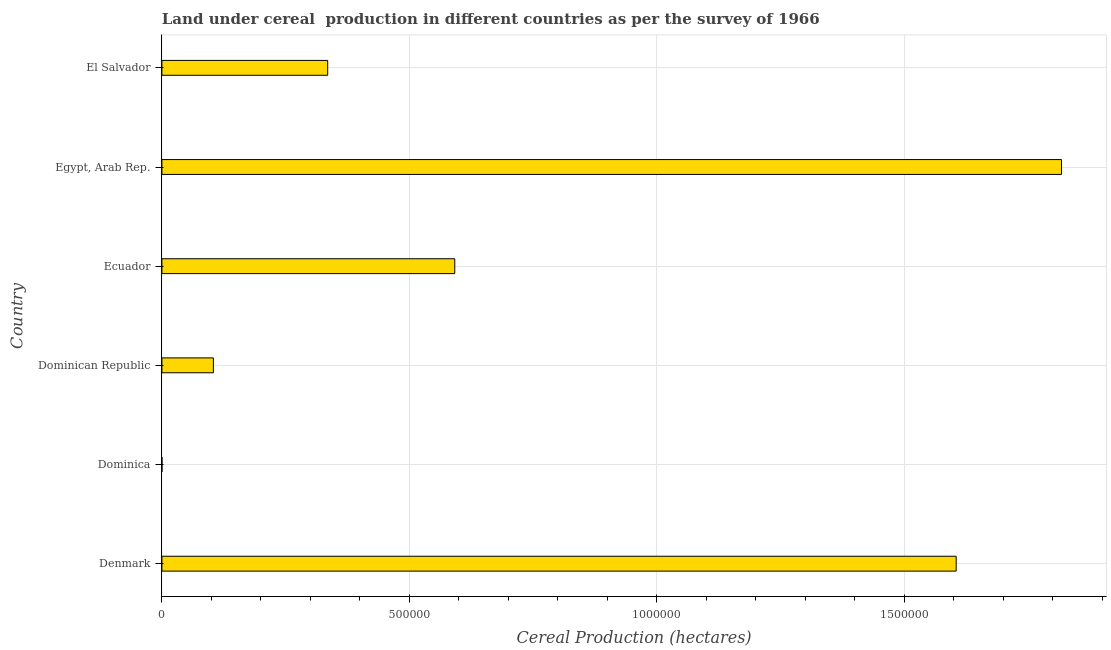Does the graph contain any zero values?
Make the answer very short. No. Does the graph contain grids?
Your answer should be very brief. Yes. What is the title of the graph?
Provide a succinct answer. Land under cereal  production in different countries as per the survey of 1966. What is the label or title of the X-axis?
Your answer should be very brief. Cereal Production (hectares). What is the land under cereal production in Egypt, Arab Rep.?
Your answer should be very brief. 1.82e+06. Across all countries, what is the maximum land under cereal production?
Your answer should be compact. 1.82e+06. Across all countries, what is the minimum land under cereal production?
Offer a very short reply. 120. In which country was the land under cereal production maximum?
Provide a short and direct response. Egypt, Arab Rep. In which country was the land under cereal production minimum?
Ensure brevity in your answer.  Dominica. What is the sum of the land under cereal production?
Provide a succinct answer. 4.45e+06. What is the difference between the land under cereal production in Dominican Republic and Egypt, Arab Rep.?
Ensure brevity in your answer.  -1.71e+06. What is the average land under cereal production per country?
Keep it short and to the point. 7.42e+05. What is the median land under cereal production?
Your answer should be very brief. 4.63e+05. In how many countries, is the land under cereal production greater than 700000 hectares?
Provide a succinct answer. 2. Is the land under cereal production in Dominican Republic less than that in Ecuador?
Offer a very short reply. Yes. What is the difference between the highest and the second highest land under cereal production?
Your answer should be very brief. 2.13e+05. What is the difference between the highest and the lowest land under cereal production?
Give a very brief answer. 1.82e+06. How many bars are there?
Provide a succinct answer. 6. What is the difference between two consecutive major ticks on the X-axis?
Make the answer very short. 5.00e+05. What is the Cereal Production (hectares) in Denmark?
Keep it short and to the point. 1.60e+06. What is the Cereal Production (hectares) of Dominica?
Your answer should be very brief. 120. What is the Cereal Production (hectares) of Dominican Republic?
Offer a terse response. 1.04e+05. What is the Cereal Production (hectares) of Ecuador?
Provide a succinct answer. 5.92e+05. What is the Cereal Production (hectares) of Egypt, Arab Rep.?
Ensure brevity in your answer.  1.82e+06. What is the Cereal Production (hectares) in El Salvador?
Give a very brief answer. 3.35e+05. What is the difference between the Cereal Production (hectares) in Denmark and Dominica?
Offer a terse response. 1.60e+06. What is the difference between the Cereal Production (hectares) in Denmark and Dominican Republic?
Make the answer very short. 1.50e+06. What is the difference between the Cereal Production (hectares) in Denmark and Ecuador?
Provide a short and direct response. 1.01e+06. What is the difference between the Cereal Production (hectares) in Denmark and Egypt, Arab Rep.?
Ensure brevity in your answer.  -2.13e+05. What is the difference between the Cereal Production (hectares) in Denmark and El Salvador?
Offer a very short reply. 1.27e+06. What is the difference between the Cereal Production (hectares) in Dominica and Dominican Republic?
Offer a terse response. -1.04e+05. What is the difference between the Cereal Production (hectares) in Dominica and Ecuador?
Ensure brevity in your answer.  -5.92e+05. What is the difference between the Cereal Production (hectares) in Dominica and Egypt, Arab Rep.?
Ensure brevity in your answer.  -1.82e+06. What is the difference between the Cereal Production (hectares) in Dominica and El Salvador?
Your answer should be compact. -3.35e+05. What is the difference between the Cereal Production (hectares) in Dominican Republic and Ecuador?
Your response must be concise. -4.88e+05. What is the difference between the Cereal Production (hectares) in Dominican Republic and Egypt, Arab Rep.?
Keep it short and to the point. -1.71e+06. What is the difference between the Cereal Production (hectares) in Dominican Republic and El Salvador?
Offer a very short reply. -2.31e+05. What is the difference between the Cereal Production (hectares) in Ecuador and Egypt, Arab Rep.?
Your answer should be very brief. -1.23e+06. What is the difference between the Cereal Production (hectares) in Ecuador and El Salvador?
Your answer should be very brief. 2.57e+05. What is the difference between the Cereal Production (hectares) in Egypt, Arab Rep. and El Salvador?
Your response must be concise. 1.48e+06. What is the ratio of the Cereal Production (hectares) in Denmark to that in Dominica?
Ensure brevity in your answer.  1.34e+04. What is the ratio of the Cereal Production (hectares) in Denmark to that in Dominican Republic?
Make the answer very short. 15.43. What is the ratio of the Cereal Production (hectares) in Denmark to that in Ecuador?
Make the answer very short. 2.71. What is the ratio of the Cereal Production (hectares) in Denmark to that in Egypt, Arab Rep.?
Your response must be concise. 0.88. What is the ratio of the Cereal Production (hectares) in Denmark to that in El Salvador?
Ensure brevity in your answer.  4.79. What is the ratio of the Cereal Production (hectares) in Dominica to that in Dominican Republic?
Provide a short and direct response. 0. What is the ratio of the Cereal Production (hectares) in Dominica to that in Ecuador?
Your answer should be very brief. 0. What is the ratio of the Cereal Production (hectares) in Dominican Republic to that in Ecuador?
Your answer should be compact. 0.18. What is the ratio of the Cereal Production (hectares) in Dominican Republic to that in Egypt, Arab Rep.?
Your response must be concise. 0.06. What is the ratio of the Cereal Production (hectares) in Dominican Republic to that in El Salvador?
Make the answer very short. 0.31. What is the ratio of the Cereal Production (hectares) in Ecuador to that in Egypt, Arab Rep.?
Your answer should be compact. 0.33. What is the ratio of the Cereal Production (hectares) in Ecuador to that in El Salvador?
Your answer should be compact. 1.77. What is the ratio of the Cereal Production (hectares) in Egypt, Arab Rep. to that in El Salvador?
Ensure brevity in your answer.  5.43. 